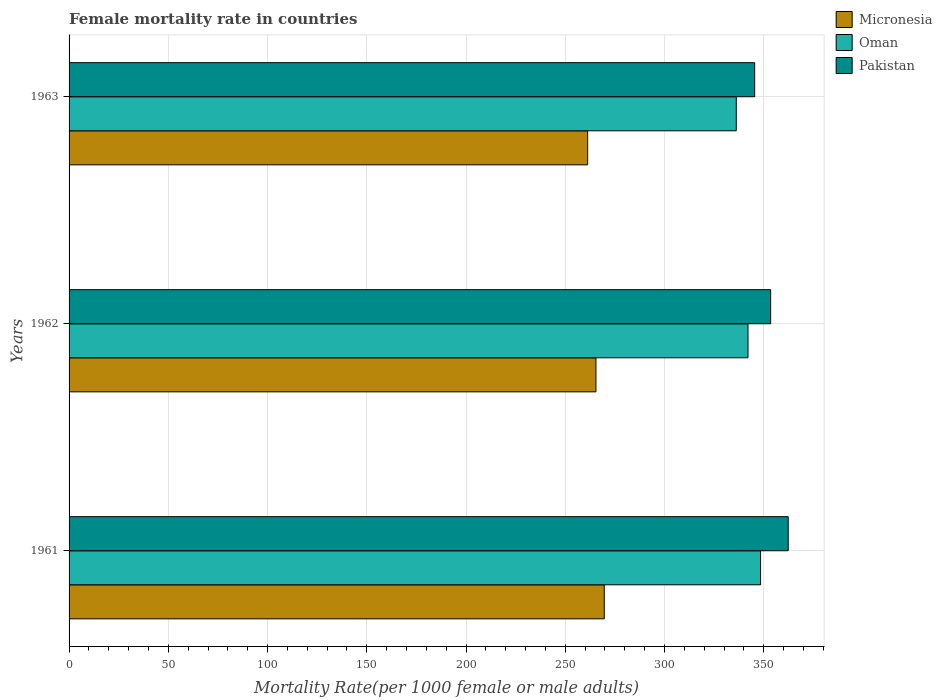How many different coloured bars are there?
Make the answer very short. 3. How many groups of bars are there?
Your answer should be very brief. 3. Are the number of bars per tick equal to the number of legend labels?
Ensure brevity in your answer.  Yes. How many bars are there on the 2nd tick from the bottom?
Offer a very short reply. 3. In how many cases, is the number of bars for a given year not equal to the number of legend labels?
Provide a short and direct response. 0. What is the female mortality rate in Pakistan in 1963?
Provide a succinct answer. 345.45. Across all years, what is the maximum female mortality rate in Oman?
Provide a short and direct response. 348.42. Across all years, what is the minimum female mortality rate in Pakistan?
Your response must be concise. 345.45. In which year was the female mortality rate in Oman maximum?
Offer a very short reply. 1961. In which year was the female mortality rate in Pakistan minimum?
Provide a short and direct response. 1963. What is the total female mortality rate in Oman in the graph?
Keep it short and to the point. 1026.69. What is the difference between the female mortality rate in Pakistan in 1962 and that in 1963?
Provide a short and direct response. 8.04. What is the difference between the female mortality rate in Oman in 1962 and the female mortality rate in Micronesia in 1963?
Provide a short and direct response. 80.8. What is the average female mortality rate in Oman per year?
Provide a succinct answer. 342.23. In the year 1961, what is the difference between the female mortality rate in Pakistan and female mortality rate in Micronesia?
Provide a succinct answer. 92.68. What is the ratio of the female mortality rate in Oman in 1961 to that in 1963?
Give a very brief answer. 1.04. What is the difference between the highest and the second highest female mortality rate in Micronesia?
Offer a very short reply. 4.18. What is the difference between the highest and the lowest female mortality rate in Micronesia?
Ensure brevity in your answer.  8.37. What does the 2nd bar from the top in 1961 represents?
Your answer should be very brief. Oman. Are all the bars in the graph horizontal?
Your answer should be very brief. Yes. How many years are there in the graph?
Provide a succinct answer. 3. Does the graph contain any zero values?
Your answer should be compact. No. Where does the legend appear in the graph?
Your answer should be very brief. Top right. How are the legend labels stacked?
Offer a terse response. Vertical. What is the title of the graph?
Give a very brief answer. Female mortality rate in countries. Does "Central Europe" appear as one of the legend labels in the graph?
Your answer should be very brief. No. What is the label or title of the X-axis?
Your answer should be compact. Mortality Rate(per 1000 female or male adults). What is the label or title of the Y-axis?
Your response must be concise. Years. What is the Mortality Rate(per 1000 female or male adults) of Micronesia in 1961?
Offer a very short reply. 269.66. What is the Mortality Rate(per 1000 female or male adults) of Oman in 1961?
Provide a succinct answer. 348.42. What is the Mortality Rate(per 1000 female or male adults) of Pakistan in 1961?
Give a very brief answer. 362.34. What is the Mortality Rate(per 1000 female or male adults) in Micronesia in 1962?
Keep it short and to the point. 265.48. What is the Mortality Rate(per 1000 female or male adults) of Oman in 1962?
Your answer should be compact. 342.09. What is the Mortality Rate(per 1000 female or male adults) in Pakistan in 1962?
Ensure brevity in your answer.  353.5. What is the Mortality Rate(per 1000 female or male adults) in Micronesia in 1963?
Your response must be concise. 261.29. What is the Mortality Rate(per 1000 female or male adults) of Oman in 1963?
Provide a short and direct response. 336.18. What is the Mortality Rate(per 1000 female or male adults) of Pakistan in 1963?
Keep it short and to the point. 345.45. Across all years, what is the maximum Mortality Rate(per 1000 female or male adults) in Micronesia?
Your answer should be compact. 269.66. Across all years, what is the maximum Mortality Rate(per 1000 female or male adults) in Oman?
Your response must be concise. 348.42. Across all years, what is the maximum Mortality Rate(per 1000 female or male adults) of Pakistan?
Ensure brevity in your answer.  362.34. Across all years, what is the minimum Mortality Rate(per 1000 female or male adults) in Micronesia?
Offer a very short reply. 261.29. Across all years, what is the minimum Mortality Rate(per 1000 female or male adults) of Oman?
Your answer should be compact. 336.18. Across all years, what is the minimum Mortality Rate(per 1000 female or male adults) of Pakistan?
Offer a terse response. 345.45. What is the total Mortality Rate(per 1000 female or male adults) of Micronesia in the graph?
Make the answer very short. 796.43. What is the total Mortality Rate(per 1000 female or male adults) of Oman in the graph?
Keep it short and to the point. 1026.69. What is the total Mortality Rate(per 1000 female or male adults) of Pakistan in the graph?
Your response must be concise. 1061.29. What is the difference between the Mortality Rate(per 1000 female or male adults) in Micronesia in 1961 and that in 1962?
Your answer should be very brief. 4.18. What is the difference between the Mortality Rate(per 1000 female or male adults) of Oman in 1961 and that in 1962?
Your response must be concise. 6.33. What is the difference between the Mortality Rate(per 1000 female or male adults) in Pakistan in 1961 and that in 1962?
Your answer should be compact. 8.84. What is the difference between the Mortality Rate(per 1000 female or male adults) of Micronesia in 1961 and that in 1963?
Your answer should be very brief. 8.37. What is the difference between the Mortality Rate(per 1000 female or male adults) in Oman in 1961 and that in 1963?
Ensure brevity in your answer.  12.25. What is the difference between the Mortality Rate(per 1000 female or male adults) of Pakistan in 1961 and that in 1963?
Provide a short and direct response. 16.89. What is the difference between the Mortality Rate(per 1000 female or male adults) in Micronesia in 1962 and that in 1963?
Offer a very short reply. 4.18. What is the difference between the Mortality Rate(per 1000 female or male adults) of Oman in 1962 and that in 1963?
Your answer should be compact. 5.91. What is the difference between the Mortality Rate(per 1000 female or male adults) of Pakistan in 1962 and that in 1963?
Your answer should be very brief. 8.04. What is the difference between the Mortality Rate(per 1000 female or male adults) in Micronesia in 1961 and the Mortality Rate(per 1000 female or male adults) in Oman in 1962?
Your answer should be compact. -72.43. What is the difference between the Mortality Rate(per 1000 female or male adults) in Micronesia in 1961 and the Mortality Rate(per 1000 female or male adults) in Pakistan in 1962?
Ensure brevity in your answer.  -83.84. What is the difference between the Mortality Rate(per 1000 female or male adults) in Oman in 1961 and the Mortality Rate(per 1000 female or male adults) in Pakistan in 1962?
Your response must be concise. -5.07. What is the difference between the Mortality Rate(per 1000 female or male adults) in Micronesia in 1961 and the Mortality Rate(per 1000 female or male adults) in Oman in 1963?
Your response must be concise. -66.52. What is the difference between the Mortality Rate(per 1000 female or male adults) in Micronesia in 1961 and the Mortality Rate(per 1000 female or male adults) in Pakistan in 1963?
Make the answer very short. -75.79. What is the difference between the Mortality Rate(per 1000 female or male adults) in Oman in 1961 and the Mortality Rate(per 1000 female or male adults) in Pakistan in 1963?
Your answer should be very brief. 2.97. What is the difference between the Mortality Rate(per 1000 female or male adults) in Micronesia in 1962 and the Mortality Rate(per 1000 female or male adults) in Oman in 1963?
Ensure brevity in your answer.  -70.7. What is the difference between the Mortality Rate(per 1000 female or male adults) in Micronesia in 1962 and the Mortality Rate(per 1000 female or male adults) in Pakistan in 1963?
Offer a terse response. -79.98. What is the difference between the Mortality Rate(per 1000 female or male adults) of Oman in 1962 and the Mortality Rate(per 1000 female or male adults) of Pakistan in 1963?
Ensure brevity in your answer.  -3.36. What is the average Mortality Rate(per 1000 female or male adults) in Micronesia per year?
Ensure brevity in your answer.  265.48. What is the average Mortality Rate(per 1000 female or male adults) of Oman per year?
Give a very brief answer. 342.23. What is the average Mortality Rate(per 1000 female or male adults) of Pakistan per year?
Give a very brief answer. 353.76. In the year 1961, what is the difference between the Mortality Rate(per 1000 female or male adults) of Micronesia and Mortality Rate(per 1000 female or male adults) of Oman?
Your answer should be very brief. -78.76. In the year 1961, what is the difference between the Mortality Rate(per 1000 female or male adults) of Micronesia and Mortality Rate(per 1000 female or male adults) of Pakistan?
Your answer should be very brief. -92.68. In the year 1961, what is the difference between the Mortality Rate(per 1000 female or male adults) in Oman and Mortality Rate(per 1000 female or male adults) in Pakistan?
Provide a short and direct response. -13.92. In the year 1962, what is the difference between the Mortality Rate(per 1000 female or male adults) in Micronesia and Mortality Rate(per 1000 female or male adults) in Oman?
Your answer should be compact. -76.61. In the year 1962, what is the difference between the Mortality Rate(per 1000 female or male adults) in Micronesia and Mortality Rate(per 1000 female or male adults) in Pakistan?
Keep it short and to the point. -88.02. In the year 1962, what is the difference between the Mortality Rate(per 1000 female or male adults) in Oman and Mortality Rate(per 1000 female or male adults) in Pakistan?
Your answer should be compact. -11.41. In the year 1963, what is the difference between the Mortality Rate(per 1000 female or male adults) of Micronesia and Mortality Rate(per 1000 female or male adults) of Oman?
Give a very brief answer. -74.88. In the year 1963, what is the difference between the Mortality Rate(per 1000 female or male adults) of Micronesia and Mortality Rate(per 1000 female or male adults) of Pakistan?
Keep it short and to the point. -84.16. In the year 1963, what is the difference between the Mortality Rate(per 1000 female or male adults) of Oman and Mortality Rate(per 1000 female or male adults) of Pakistan?
Make the answer very short. -9.28. What is the ratio of the Mortality Rate(per 1000 female or male adults) of Micronesia in 1961 to that in 1962?
Your answer should be very brief. 1.02. What is the ratio of the Mortality Rate(per 1000 female or male adults) of Oman in 1961 to that in 1962?
Your response must be concise. 1.02. What is the ratio of the Mortality Rate(per 1000 female or male adults) in Pakistan in 1961 to that in 1962?
Make the answer very short. 1.02. What is the ratio of the Mortality Rate(per 1000 female or male adults) of Micronesia in 1961 to that in 1963?
Ensure brevity in your answer.  1.03. What is the ratio of the Mortality Rate(per 1000 female or male adults) of Oman in 1961 to that in 1963?
Offer a terse response. 1.04. What is the ratio of the Mortality Rate(per 1000 female or male adults) in Pakistan in 1961 to that in 1963?
Offer a very short reply. 1.05. What is the ratio of the Mortality Rate(per 1000 female or male adults) of Micronesia in 1962 to that in 1963?
Provide a short and direct response. 1.02. What is the ratio of the Mortality Rate(per 1000 female or male adults) in Oman in 1962 to that in 1963?
Offer a terse response. 1.02. What is the ratio of the Mortality Rate(per 1000 female or male adults) in Pakistan in 1962 to that in 1963?
Give a very brief answer. 1.02. What is the difference between the highest and the second highest Mortality Rate(per 1000 female or male adults) in Micronesia?
Your response must be concise. 4.18. What is the difference between the highest and the second highest Mortality Rate(per 1000 female or male adults) in Oman?
Keep it short and to the point. 6.33. What is the difference between the highest and the second highest Mortality Rate(per 1000 female or male adults) of Pakistan?
Your answer should be compact. 8.84. What is the difference between the highest and the lowest Mortality Rate(per 1000 female or male adults) in Micronesia?
Give a very brief answer. 8.37. What is the difference between the highest and the lowest Mortality Rate(per 1000 female or male adults) of Oman?
Offer a very short reply. 12.25. What is the difference between the highest and the lowest Mortality Rate(per 1000 female or male adults) of Pakistan?
Your answer should be very brief. 16.89. 